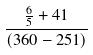Convert formula to latex. <formula><loc_0><loc_0><loc_500><loc_500>\frac { \frac { 6 } { 5 } + 4 1 } { ( 3 6 0 - 2 5 1 ) }</formula> 